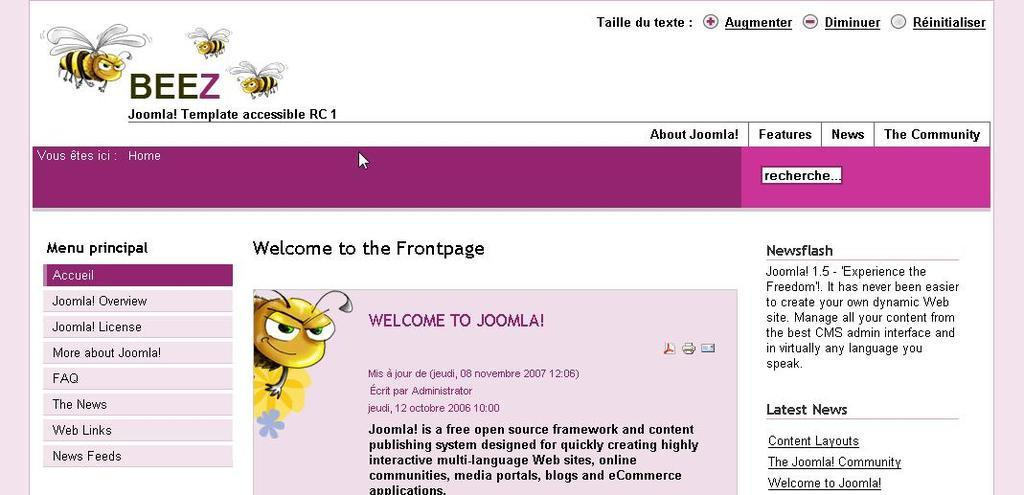What type of image is shown in the screenshot? The image is a screenshot of a monitor screen. What can be seen on the screen? There is text visible in the image, as well as cartoon images of bees. What type of war is depicted in the image? There is no war depicted in the image; it features text and cartoon images of bees. Can you see any jails or prisoners in the image? There are no jails or prisoners present in the image. 